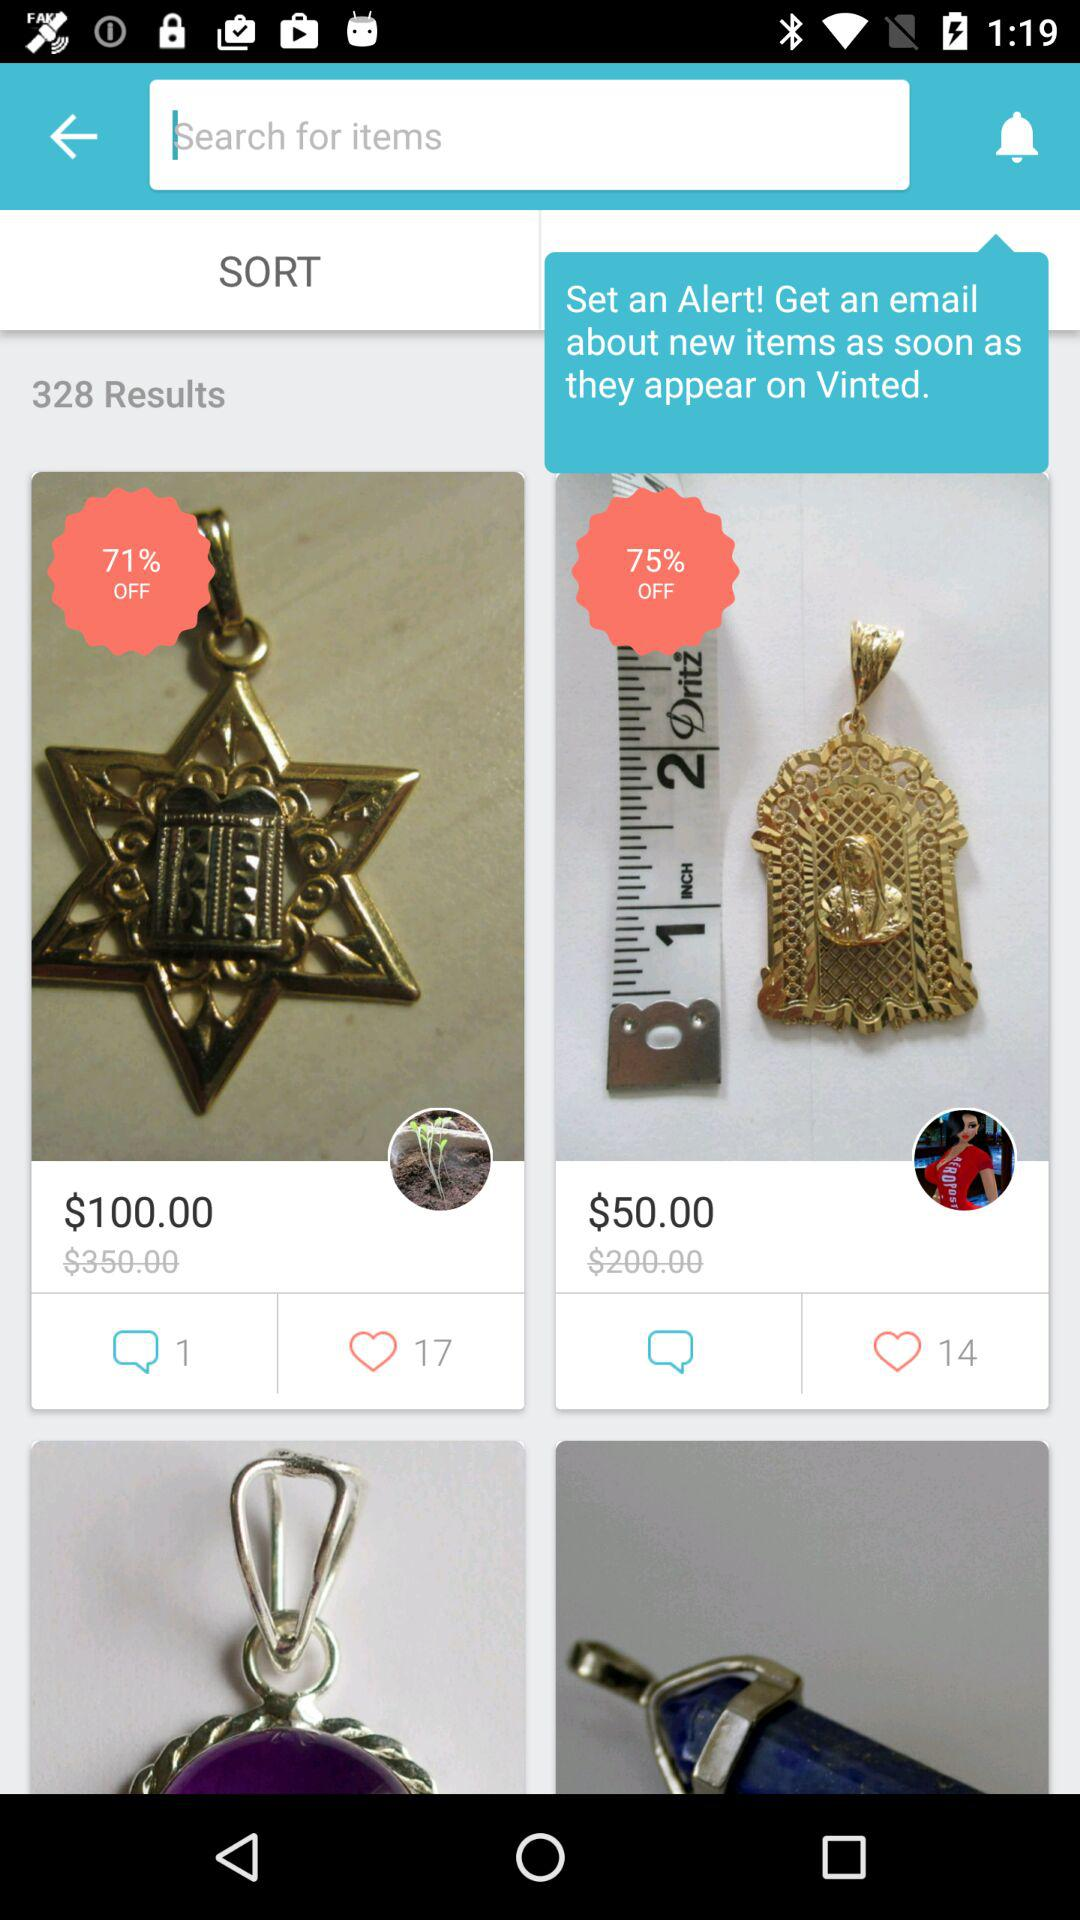What is the discount on the product with a price of $50.00? The discount on the product with a price of $50.00 is 75%. 